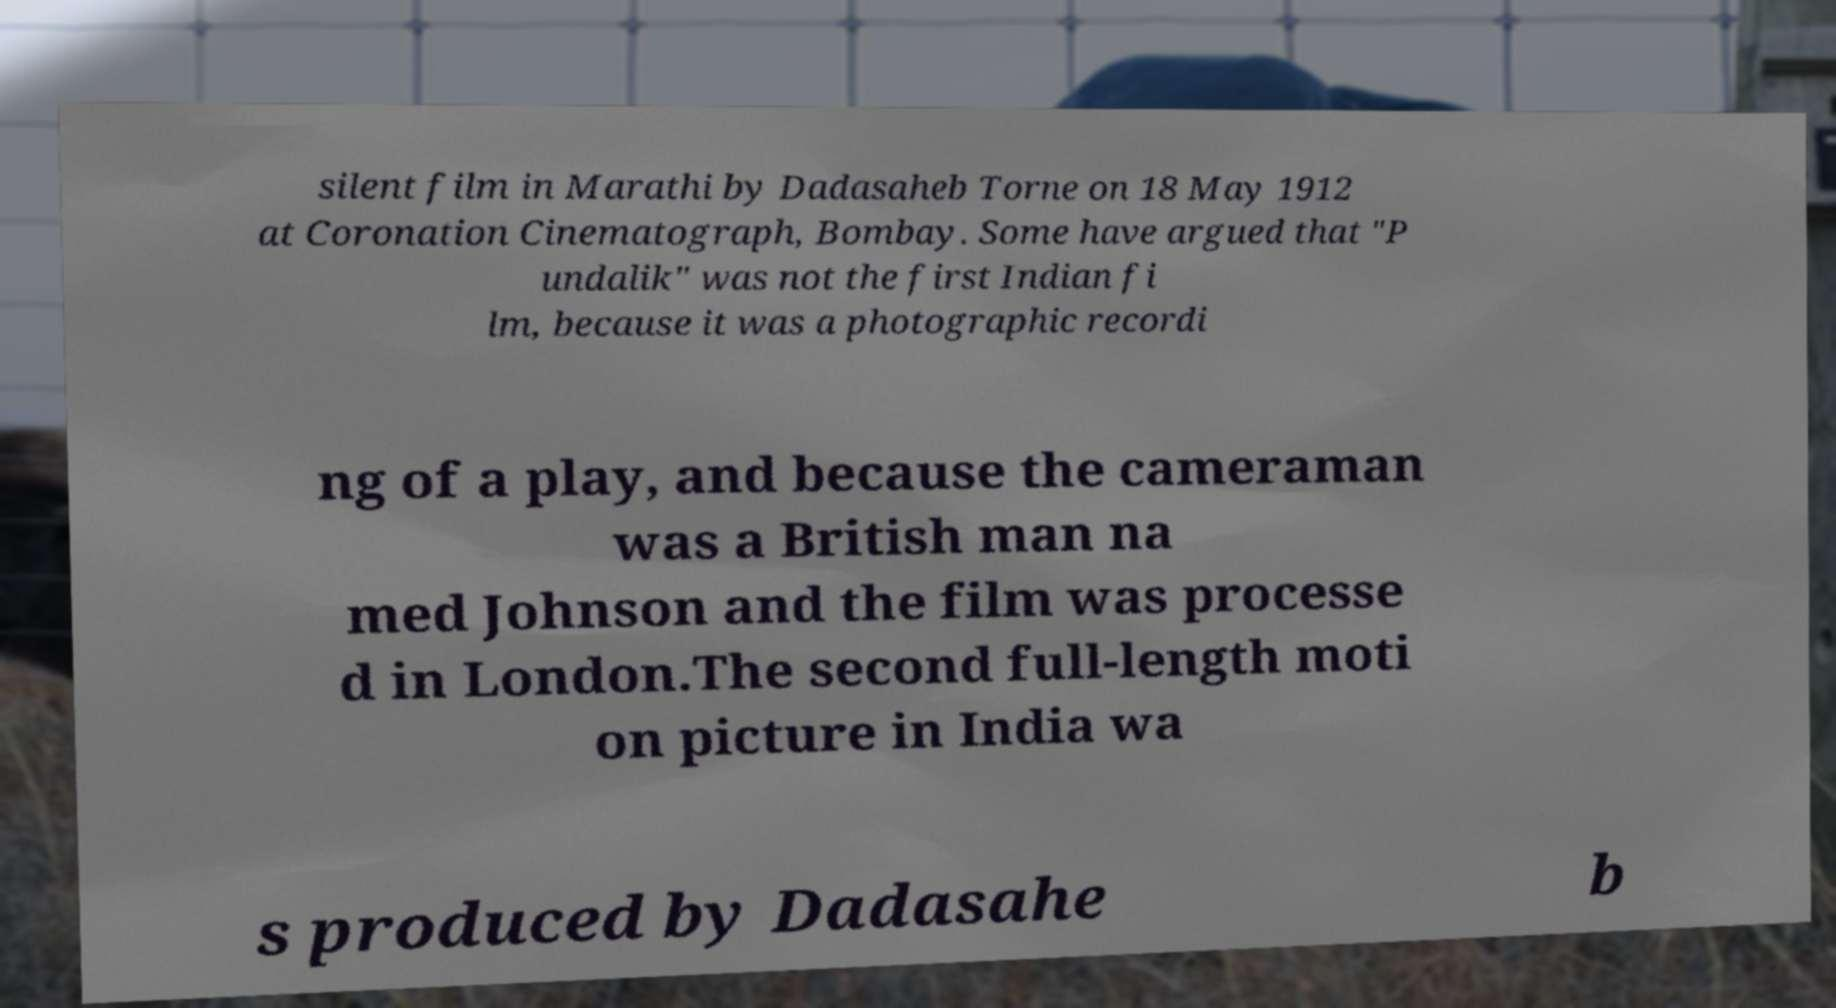What messages or text are displayed in this image? I need them in a readable, typed format. silent film in Marathi by Dadasaheb Torne on 18 May 1912 at Coronation Cinematograph, Bombay. Some have argued that "P undalik" was not the first Indian fi lm, because it was a photographic recordi ng of a play, and because the cameraman was a British man na med Johnson and the film was processe d in London.The second full-length moti on picture in India wa s produced by Dadasahe b 